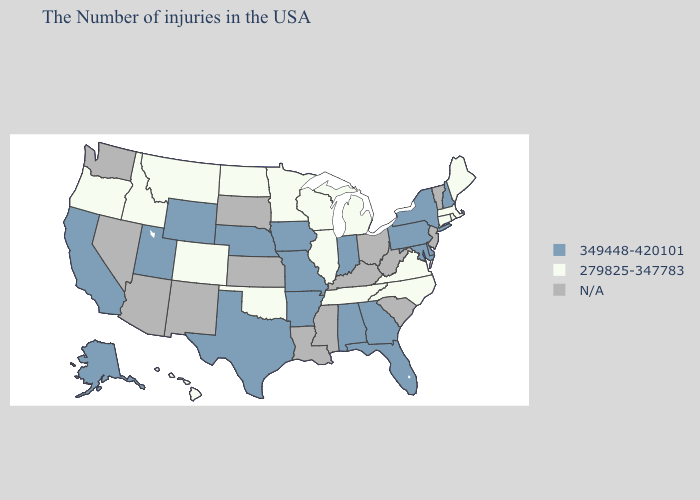What is the highest value in states that border Indiana?
Concise answer only. 279825-347783. Name the states that have a value in the range N/A?
Be succinct. Vermont, New Jersey, South Carolina, West Virginia, Ohio, Kentucky, Mississippi, Louisiana, Kansas, South Dakota, New Mexico, Arizona, Nevada, Washington. What is the highest value in the West ?
Keep it brief. 349448-420101. Does Montana have the highest value in the USA?
Keep it brief. No. What is the highest value in the MidWest ?
Give a very brief answer. 349448-420101. Among the states that border Nebraska , which have the lowest value?
Keep it brief. Colorado. Among the states that border Michigan , does Wisconsin have the highest value?
Short answer required. No. Among the states that border Nebraska , which have the lowest value?
Be succinct. Colorado. What is the value of Louisiana?
Write a very short answer. N/A. Which states hav the highest value in the West?
Be succinct. Wyoming, Utah, California, Alaska. Name the states that have a value in the range N/A?
Write a very short answer. Vermont, New Jersey, South Carolina, West Virginia, Ohio, Kentucky, Mississippi, Louisiana, Kansas, South Dakota, New Mexico, Arizona, Nevada, Washington. Among the states that border Kentucky , does Indiana have the lowest value?
Give a very brief answer. No. Does New York have the lowest value in the USA?
Concise answer only. No. What is the lowest value in the USA?
Be succinct. 279825-347783. What is the value of Texas?
Concise answer only. 349448-420101. 